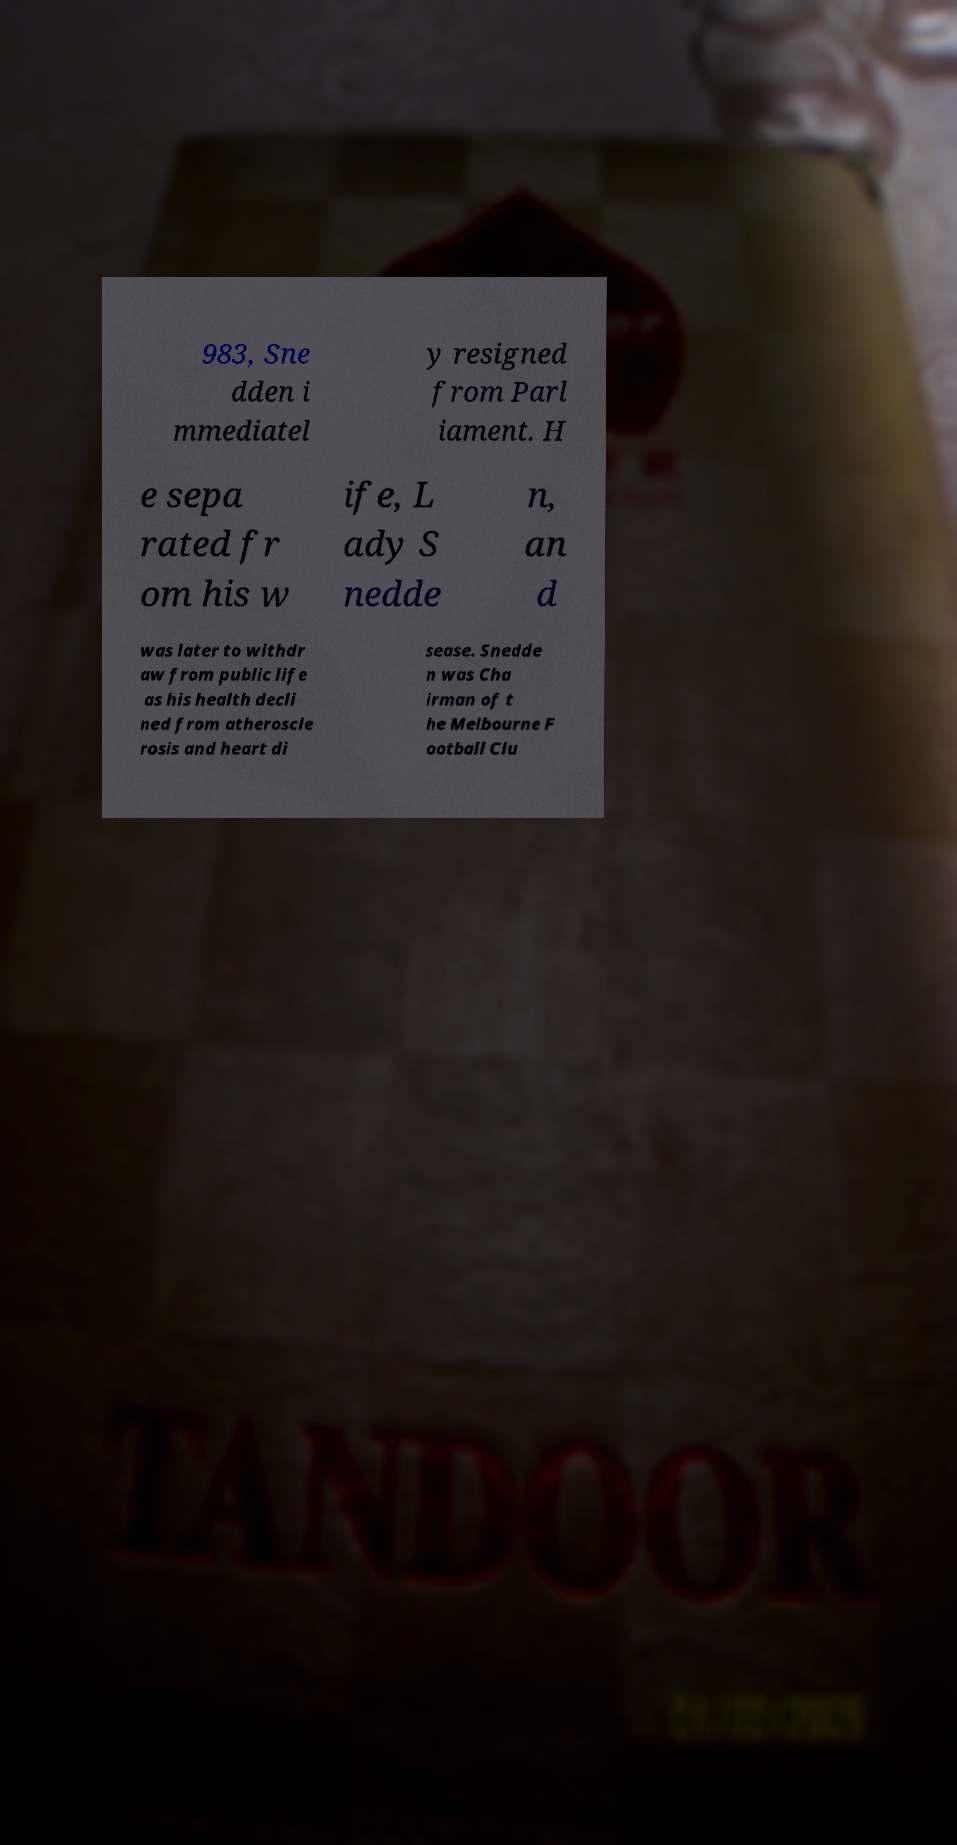What messages or text are displayed in this image? I need them in a readable, typed format. 983, Sne dden i mmediatel y resigned from Parl iament. H e sepa rated fr om his w ife, L ady S nedde n, an d was later to withdr aw from public life as his health decli ned from atheroscle rosis and heart di sease. Snedde n was Cha irman of t he Melbourne F ootball Clu 